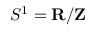<formula> <loc_0><loc_0><loc_500><loc_500>S ^ { 1 } = R / Z</formula> 